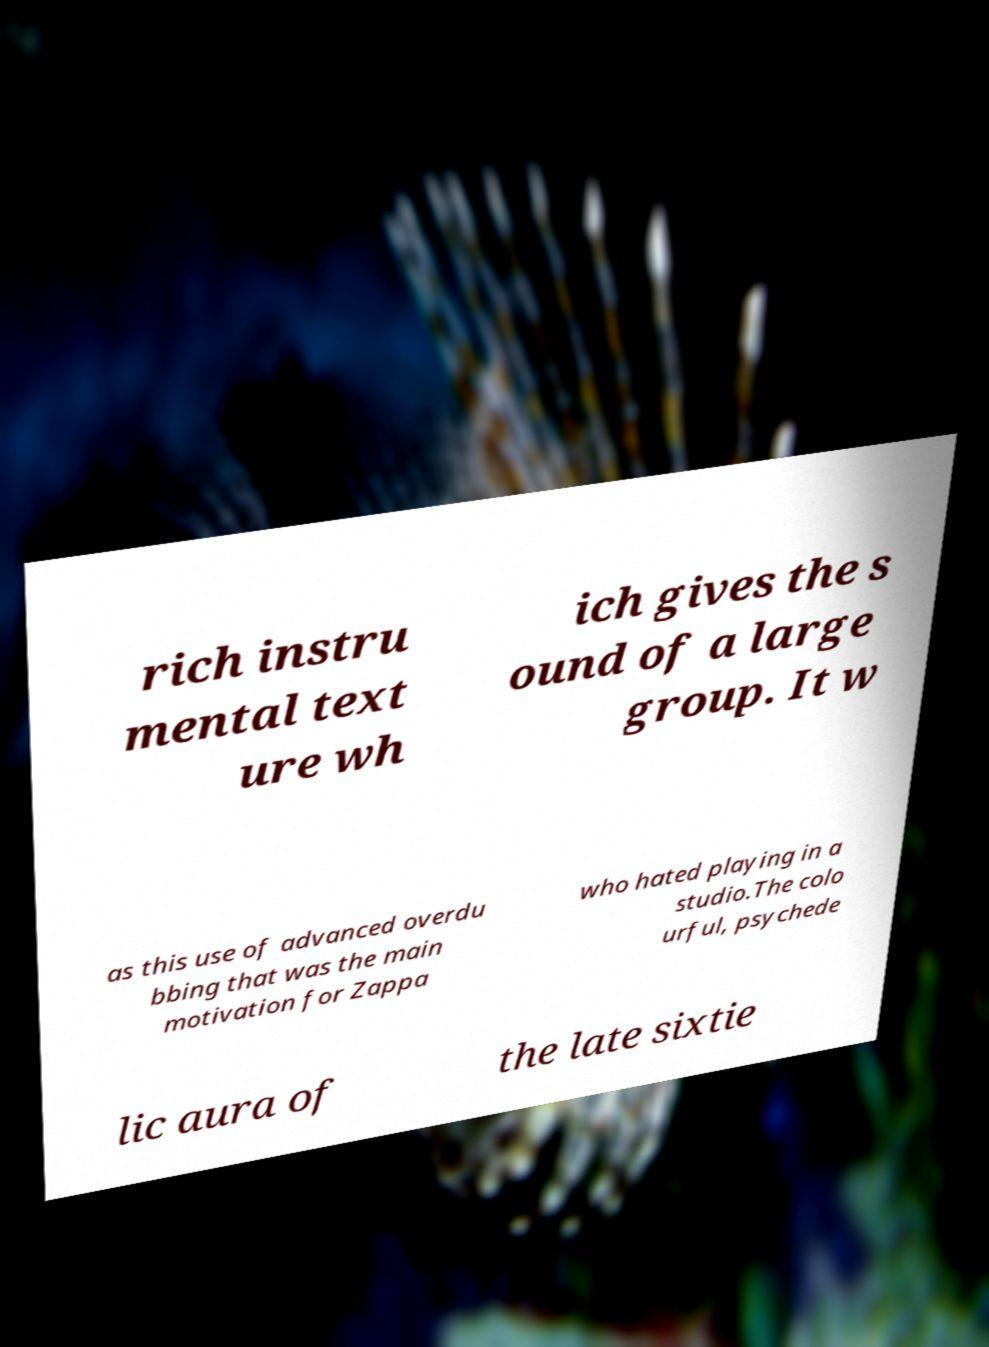Can you accurately transcribe the text from the provided image for me? rich instru mental text ure wh ich gives the s ound of a large group. It w as this use of advanced overdu bbing that was the main motivation for Zappa who hated playing in a studio.The colo urful, psychede lic aura of the late sixtie 